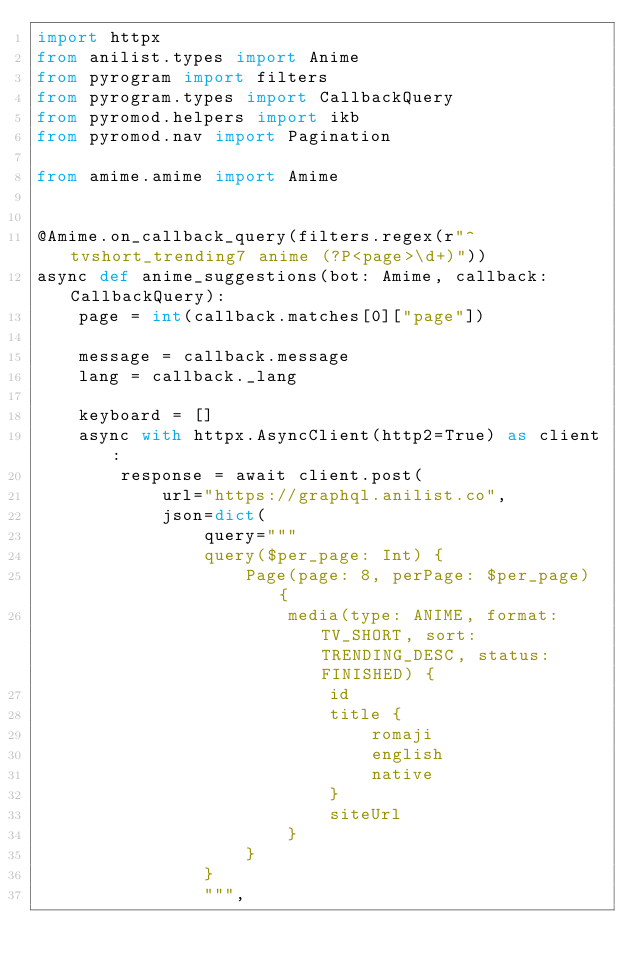<code> <loc_0><loc_0><loc_500><loc_500><_Python_>import httpx
from anilist.types import Anime
from pyrogram import filters
from pyrogram.types import CallbackQuery
from pyromod.helpers import ikb
from pyromod.nav import Pagination

from amime.amime import Amime


@Amime.on_callback_query(filters.regex(r"^tvshort_trending7 anime (?P<page>\d+)"))
async def anime_suggestions(bot: Amime, callback: CallbackQuery):
    page = int(callback.matches[0]["page"])

    message = callback.message
    lang = callback._lang

    keyboard = []
    async with httpx.AsyncClient(http2=True) as client:
        response = await client.post(
            url="https://graphql.anilist.co",
            json=dict(
                query="""
                query($per_page: Int) {
                    Page(page: 8, perPage: $per_page) {
                        media(type: ANIME, format: TV_SHORT, sort: TRENDING_DESC, status: FINISHED) {
                            id
                            title {
                                romaji
                                english
                                native
                            }
                            siteUrl
                        }
                    }
                }
                """,</code> 